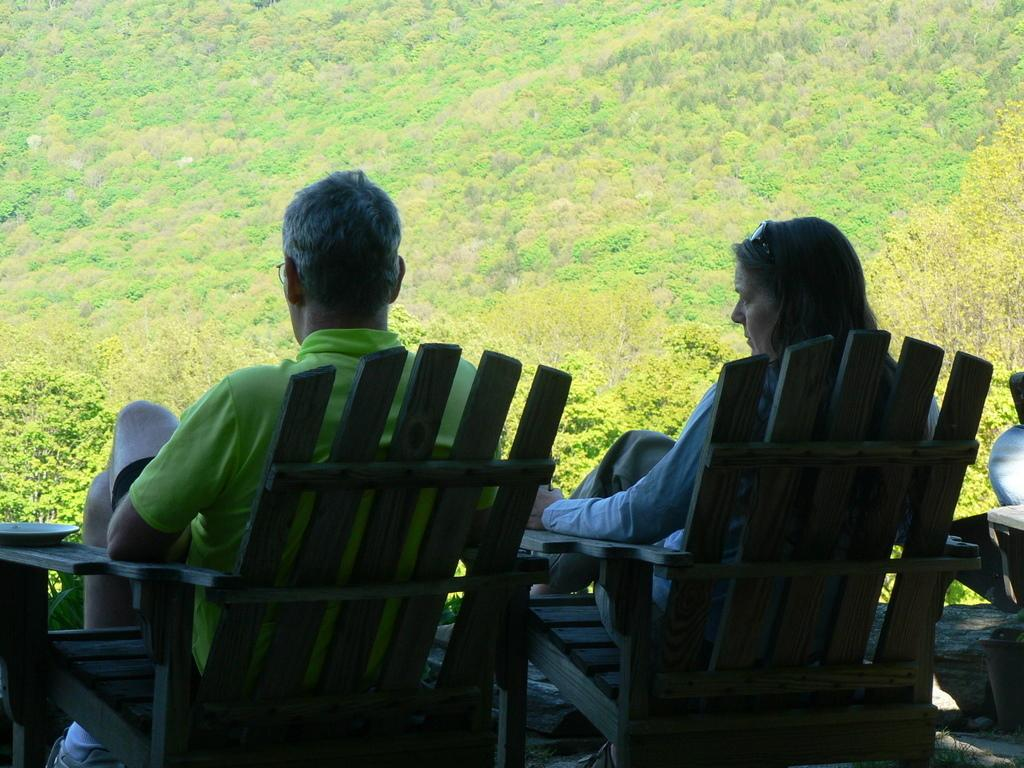Who is present in the image? There is a man and a woman in the image. What are the man and woman doing in the image? Both the man and woman are sitting on wooden chairs. What can be seen in the background of the image? There is a mountain view visible in the image, which includes trees. What invention is the man using to stretch the trees in the image? There is no invention or stretching of trees present in the image. 